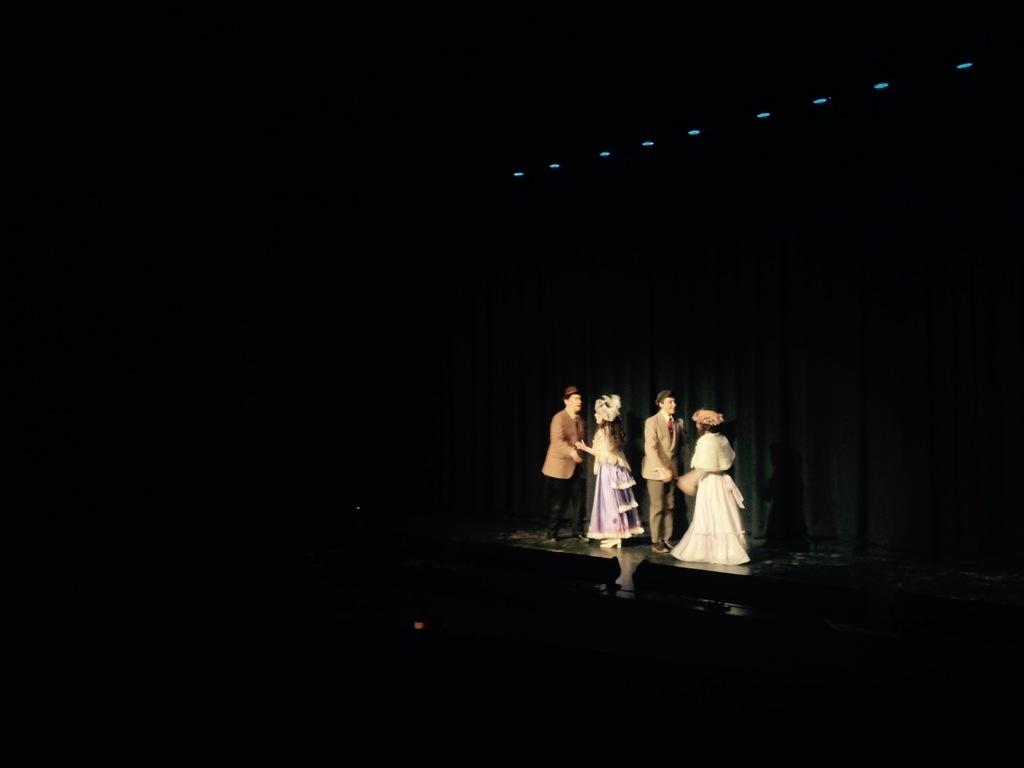How many people are present in the image? There are four people in the image, two women and two men. What are the individuals doing in the image? The individuals are standing on a stage. What can be seen above the stage in the image? There are lights above on the ceiling. What type of fish can be seen swimming in the background of the image? There are no fish present in the image; it features four people standing on a stage with lights above on the ceiling. 